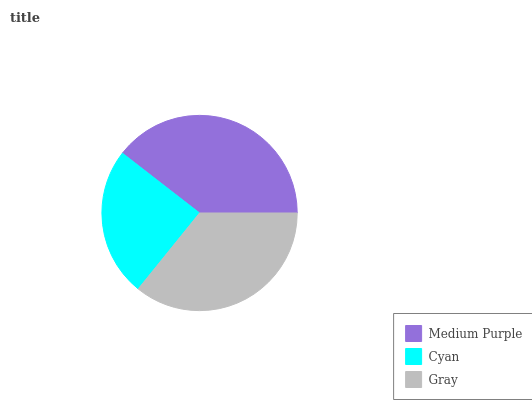Is Cyan the minimum?
Answer yes or no. Yes. Is Medium Purple the maximum?
Answer yes or no. Yes. Is Gray the minimum?
Answer yes or no. No. Is Gray the maximum?
Answer yes or no. No. Is Gray greater than Cyan?
Answer yes or no. Yes. Is Cyan less than Gray?
Answer yes or no. Yes. Is Cyan greater than Gray?
Answer yes or no. No. Is Gray less than Cyan?
Answer yes or no. No. Is Gray the high median?
Answer yes or no. Yes. Is Gray the low median?
Answer yes or no. Yes. Is Medium Purple the high median?
Answer yes or no. No. Is Medium Purple the low median?
Answer yes or no. No. 